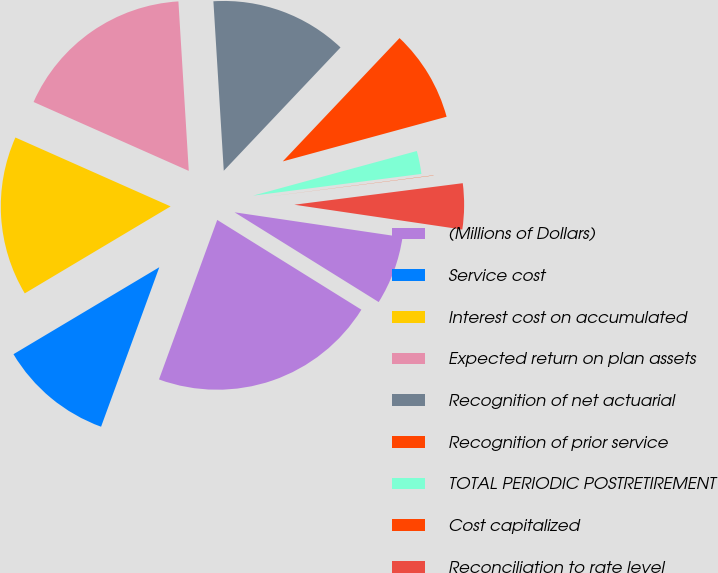<chart> <loc_0><loc_0><loc_500><loc_500><pie_chart><fcel>(Millions of Dollars)<fcel>Service cost<fcel>Interest cost on accumulated<fcel>Expected return on plan assets<fcel>Recognition of net actuarial<fcel>Recognition of prior service<fcel>TOTAL PERIODIC POSTRETIREMENT<fcel>Cost capitalized<fcel>Reconciliation to rate level<fcel>Cost charged to operating<nl><fcel>21.71%<fcel>10.87%<fcel>15.21%<fcel>17.38%<fcel>13.04%<fcel>8.7%<fcel>2.19%<fcel>0.02%<fcel>4.36%<fcel>6.53%<nl></chart> 